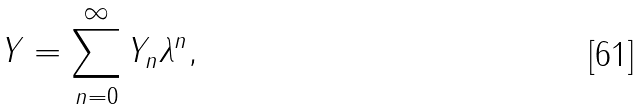<formula> <loc_0><loc_0><loc_500><loc_500>Y = \sum _ { n = 0 } ^ { \infty } Y _ { n } \lambda ^ { n } ,</formula> 